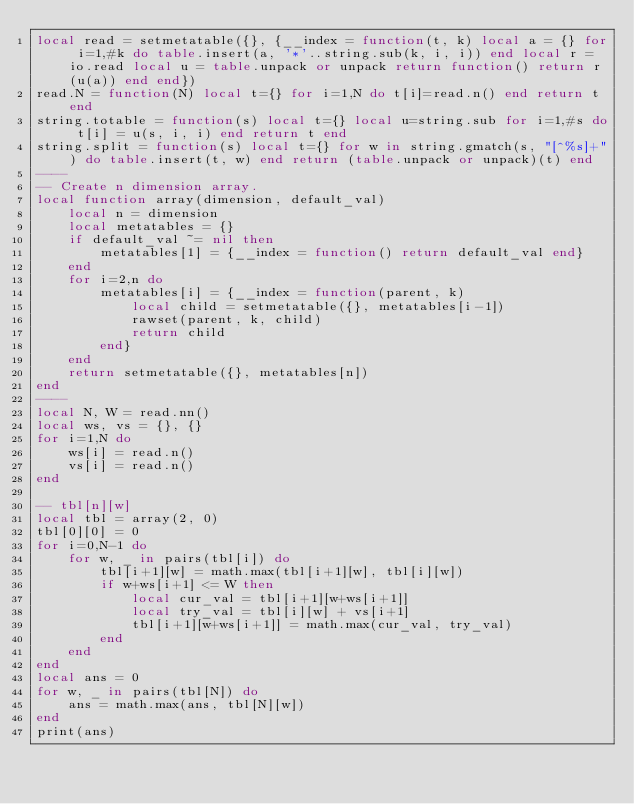Convert code to text. <code><loc_0><loc_0><loc_500><loc_500><_Lua_>local read = setmetatable({}, {__index = function(t, k) local a = {} for i=1,#k do table.insert(a, '*'..string.sub(k, i, i)) end local r = io.read local u = table.unpack or unpack return function() return r(u(a)) end end})
read.N = function(N) local t={} for i=1,N do t[i]=read.n() end return t end
string.totable = function(s) local t={} local u=string.sub for i=1,#s do t[i] = u(s, i, i) end return t end
string.split = function(s) local t={} for w in string.gmatch(s, "[^%s]+") do table.insert(t, w) end return (table.unpack or unpack)(t) end
----
-- Create n dimension array.
local function array(dimension, default_val)
    local n = dimension
    local metatables = {}
    if default_val ~= nil then
        metatables[1] = {__index = function() return default_val end}
    end
    for i=2,n do
        metatables[i] = {__index = function(parent, k)
            local child = setmetatable({}, metatables[i-1])
            rawset(parent, k, child)
            return child
        end}
    end
    return setmetatable({}, metatables[n])
end
----
local N, W = read.nn()
local ws, vs = {}, {}
for i=1,N do
    ws[i] = read.n()
    vs[i] = read.n()
end

-- tbl[n][w]
local tbl = array(2, 0)
tbl[0][0] = 0
for i=0,N-1 do
    for w, _ in pairs(tbl[i]) do
        tbl[i+1][w] = math.max(tbl[i+1][w], tbl[i][w])
        if w+ws[i+1] <= W then
            local cur_val = tbl[i+1][w+ws[i+1]]
            local try_val = tbl[i][w] + vs[i+1]
            tbl[i+1][w+ws[i+1]] = math.max(cur_val, try_val)
        end
    end
end
local ans = 0
for w, _ in pairs(tbl[N]) do
    ans = math.max(ans, tbl[N][w])
end
print(ans)</code> 